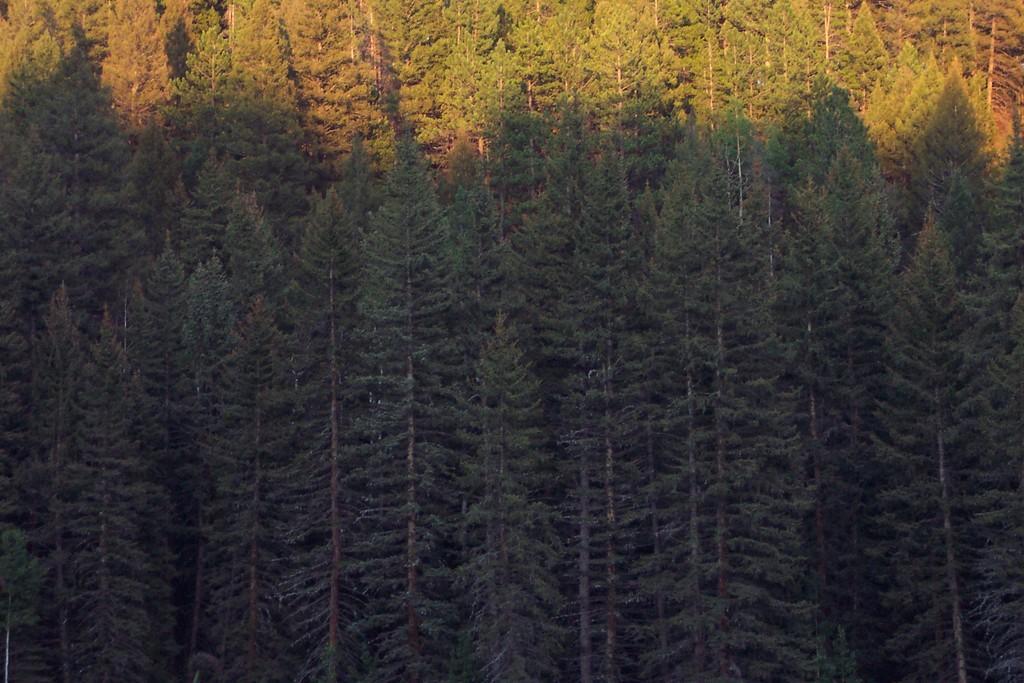Describe this image in one or two sentences. In this picture we can see trees. 